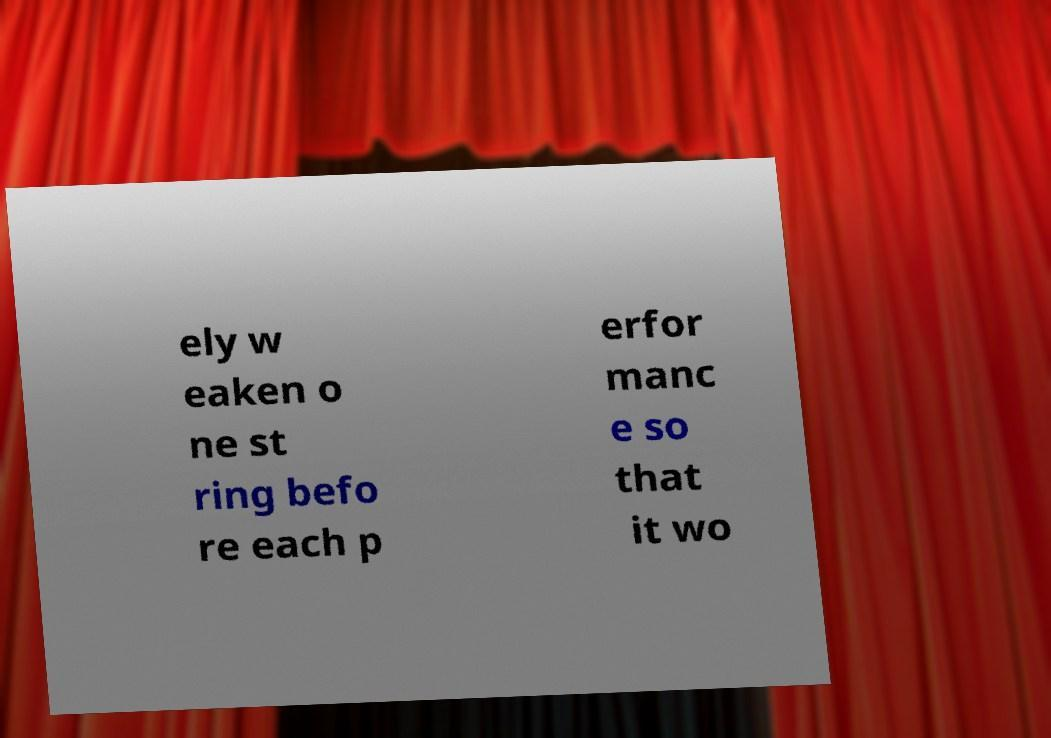I need the written content from this picture converted into text. Can you do that? ely w eaken o ne st ring befo re each p erfor manc e so that it wo 